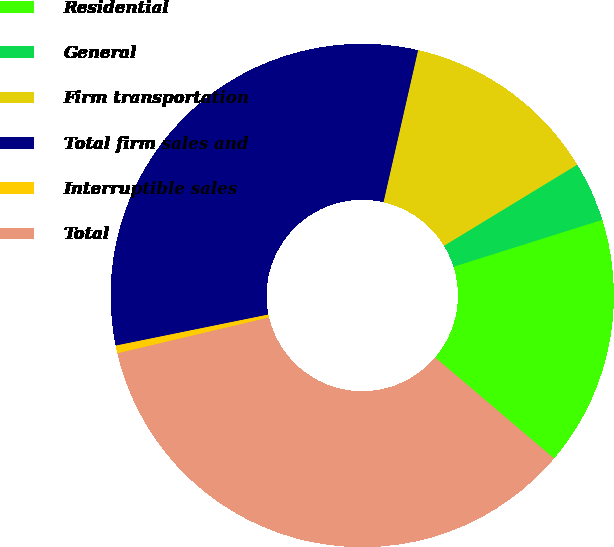<chart> <loc_0><loc_0><loc_500><loc_500><pie_chart><fcel>Residential<fcel>General<fcel>Firm transportation<fcel>Total firm sales and<fcel>Interruptible sales<fcel>Total<nl><fcel>16.08%<fcel>3.84%<fcel>12.74%<fcel>31.76%<fcel>0.5%<fcel>35.1%<nl></chart> 